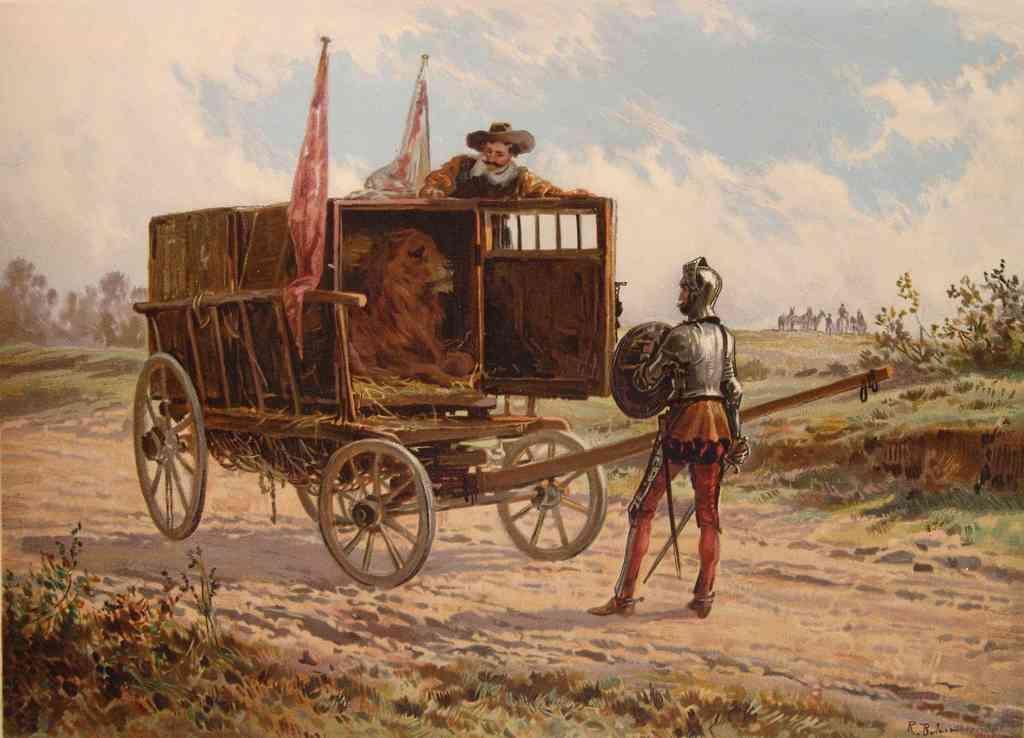How would you summarize this image in a sentence or two? This is a painting. In the image there is a cart with lion, flags and a man is standing on the cart. On the ground there is a man standing and holding the shield. In the background there are trees. At the top of the image there is a sky. 